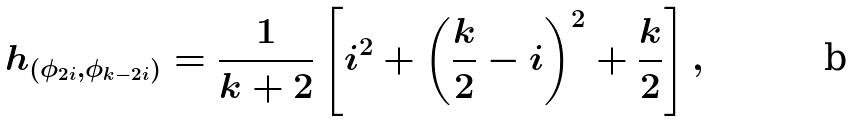<formula> <loc_0><loc_0><loc_500><loc_500>h _ { ( \phi _ { 2 i } , \phi _ { k - 2 i } ) } = \frac { 1 } { k + 2 } \left [ i ^ { 2 } + \left ( \frac { k } { 2 } - i \right ) ^ { 2 } + \frac { k } { 2 } \right ] ,</formula> 